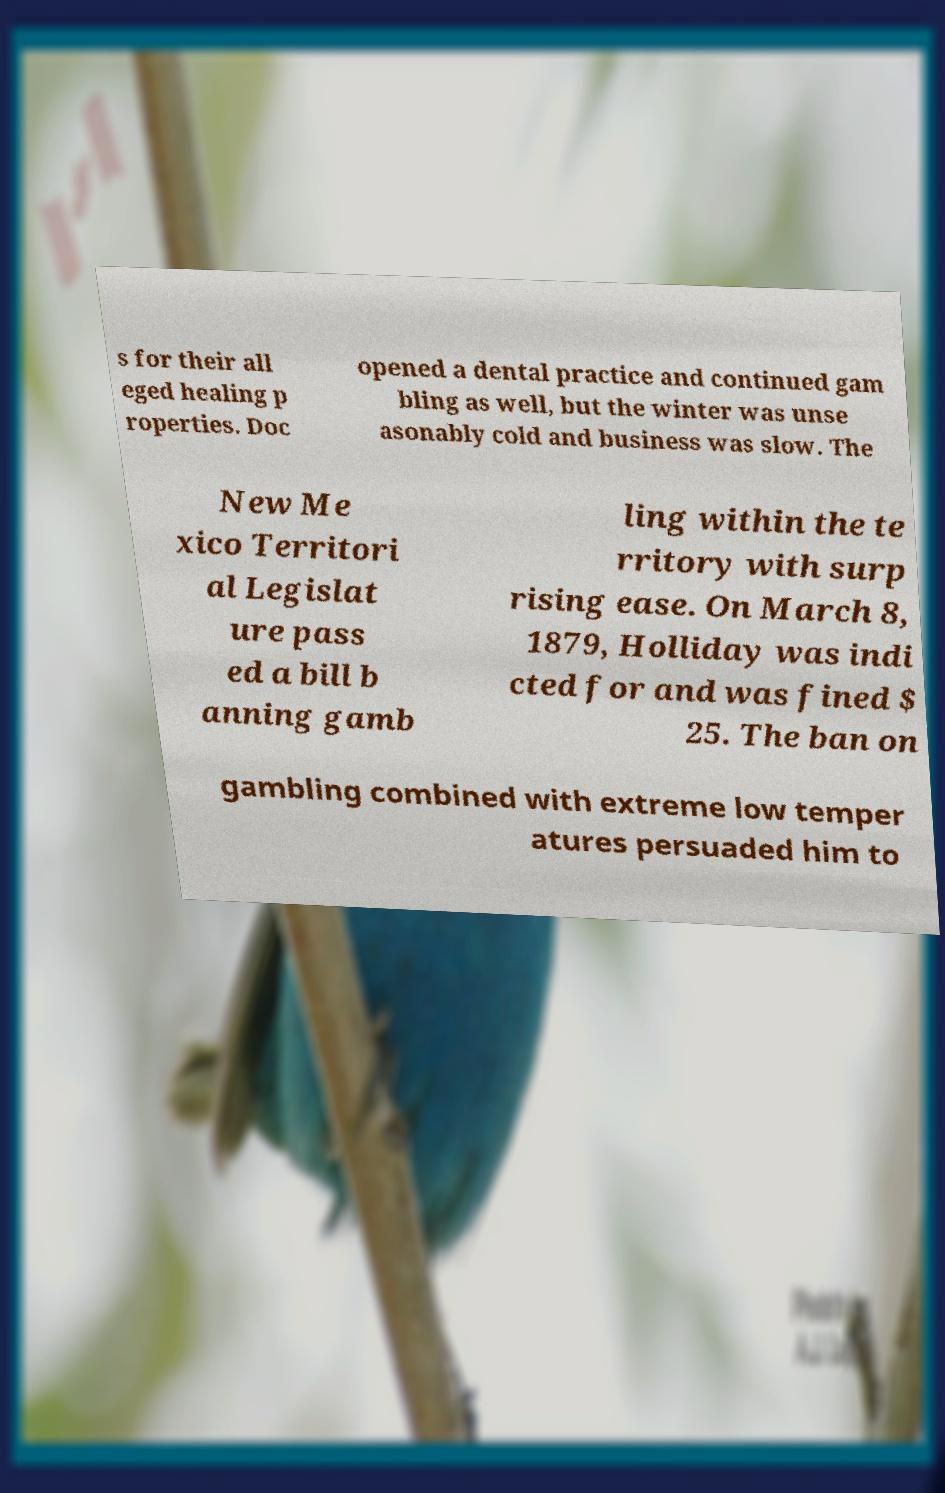Please identify and transcribe the text found in this image. s for their all eged healing p roperties. Doc opened a dental practice and continued gam bling as well, but the winter was unse asonably cold and business was slow. The New Me xico Territori al Legislat ure pass ed a bill b anning gamb ling within the te rritory with surp rising ease. On March 8, 1879, Holliday was indi cted for and was fined $ 25. The ban on gambling combined with extreme low temper atures persuaded him to 